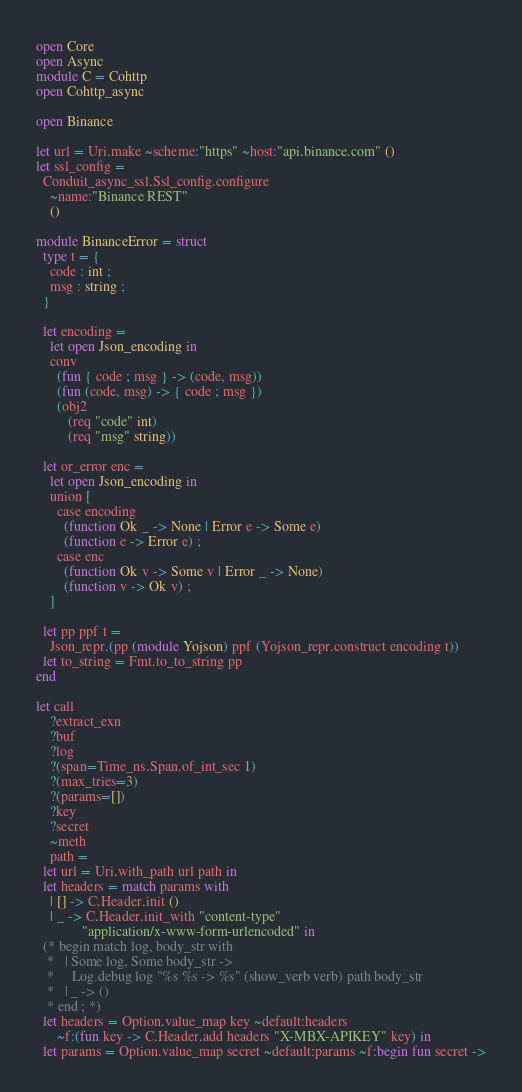<code> <loc_0><loc_0><loc_500><loc_500><_OCaml_>open Core
open Async
module C = Cohttp
open Cohttp_async

open Binance

let url = Uri.make ~scheme:"https" ~host:"api.binance.com" ()
let ssl_config =
  Conduit_async_ssl.Ssl_config.configure
    ~name:"Binance REST"
    ()

module BinanceError = struct
  type t = {
    code : int ;
    msg : string ;
  }

  let encoding =
    let open Json_encoding in
    conv
      (fun { code ; msg } -> (code, msg))
      (fun (code, msg) -> { code ; msg })
      (obj2
         (req "code" int)
         (req "msg" string))

  let or_error enc =
    let open Json_encoding in
    union [
      case encoding
        (function Ok _ -> None | Error e -> Some e)
        (function e -> Error e) ;
      case enc
        (function Ok v -> Some v | Error _ -> None)
        (function v -> Ok v) ;
    ]

  let pp ppf t =
    Json_repr.(pp (module Yojson) ppf (Yojson_repr.construct encoding t))
  let to_string = Fmt.to_to_string pp
end

let call
    ?extract_exn
    ?buf
    ?log
    ?(span=Time_ns.Span.of_int_sec 1)
    ?(max_tries=3)
    ?(params=[])
    ?key
    ?secret
    ~meth
    path =
  let url = Uri.with_path url path in
  let headers = match params with
    | [] -> C.Header.init ()
    | _ -> C.Header.init_with "content-type"
             "application/x-www-form-urlencoded" in
  (* begin match log, body_str with
   *   | Some log, Some body_str ->
   *     Log.debug log "%s %s -> %s" (show_verb verb) path body_str
   *   | _ -> ()
   * end ; *)
  let headers = Option.value_map key ~default:headers
      ~f:(fun key -> C.Header.add headers "X-MBX-APIKEY" key) in
  let params = Option.value_map secret ~default:params ~f:begin fun secret -></code> 